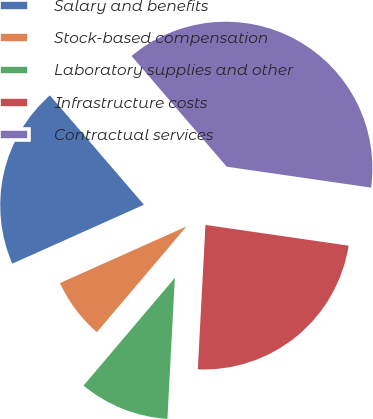Convert chart. <chart><loc_0><loc_0><loc_500><loc_500><pie_chart><fcel>Salary and benefits<fcel>Stock-based compensation<fcel>Laboratory supplies and other<fcel>Infrastructure costs<fcel>Contractual services<nl><fcel>20.4%<fcel>7.11%<fcel>10.35%<fcel>23.55%<fcel>38.59%<nl></chart> 